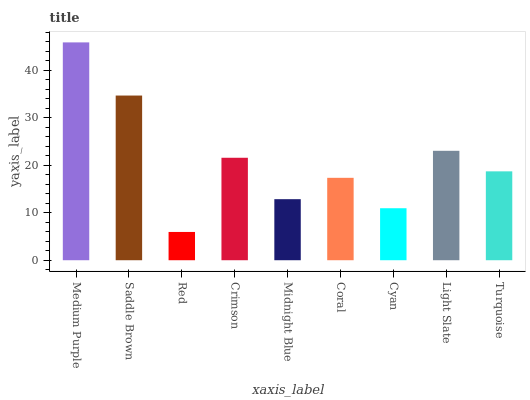Is Red the minimum?
Answer yes or no. Yes. Is Medium Purple the maximum?
Answer yes or no. Yes. Is Saddle Brown the minimum?
Answer yes or no. No. Is Saddle Brown the maximum?
Answer yes or no. No. Is Medium Purple greater than Saddle Brown?
Answer yes or no. Yes. Is Saddle Brown less than Medium Purple?
Answer yes or no. Yes. Is Saddle Brown greater than Medium Purple?
Answer yes or no. No. Is Medium Purple less than Saddle Brown?
Answer yes or no. No. Is Turquoise the high median?
Answer yes or no. Yes. Is Turquoise the low median?
Answer yes or no. Yes. Is Medium Purple the high median?
Answer yes or no. No. Is Red the low median?
Answer yes or no. No. 